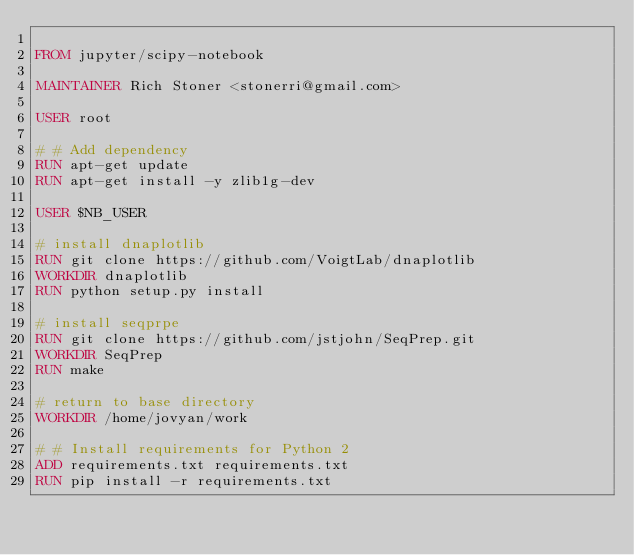<code> <loc_0><loc_0><loc_500><loc_500><_Dockerfile_>
FROM jupyter/scipy-notebook

MAINTAINER Rich Stoner <stonerri@gmail.com>

USER root

# # Add dependency
RUN apt-get update
RUN apt-get install -y zlib1g-dev

USER $NB_USER

# install dnaplotlib 
RUN git clone https://github.com/VoigtLab/dnaplotlib
WORKDIR dnaplotlib
RUN python setup.py install

# install seqprpe
RUN git clone https://github.com/jstjohn/SeqPrep.git
WORKDIR SeqPrep
RUN make

# return to base directory
WORKDIR /home/jovyan/work

# # Install requirements for Python 2
ADD requirements.txt requirements.txt
RUN pip install -r requirements.txt




</code> 